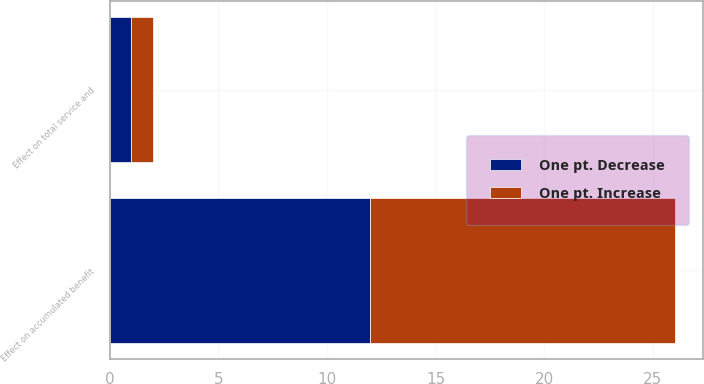Convert chart. <chart><loc_0><loc_0><loc_500><loc_500><stacked_bar_chart><ecel><fcel>Effect on total service and<fcel>Effect on accumulated benefit<nl><fcel>One pt. Increase<fcel>1<fcel>14<nl><fcel>One pt. Decrease<fcel>1<fcel>12<nl></chart> 